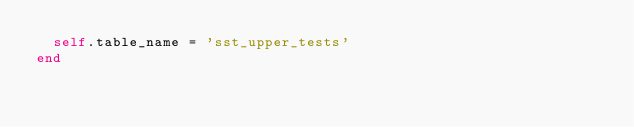<code> <loc_0><loc_0><loc_500><loc_500><_Ruby_>  self.table_name = 'sst_upper_tests'
end
</code> 